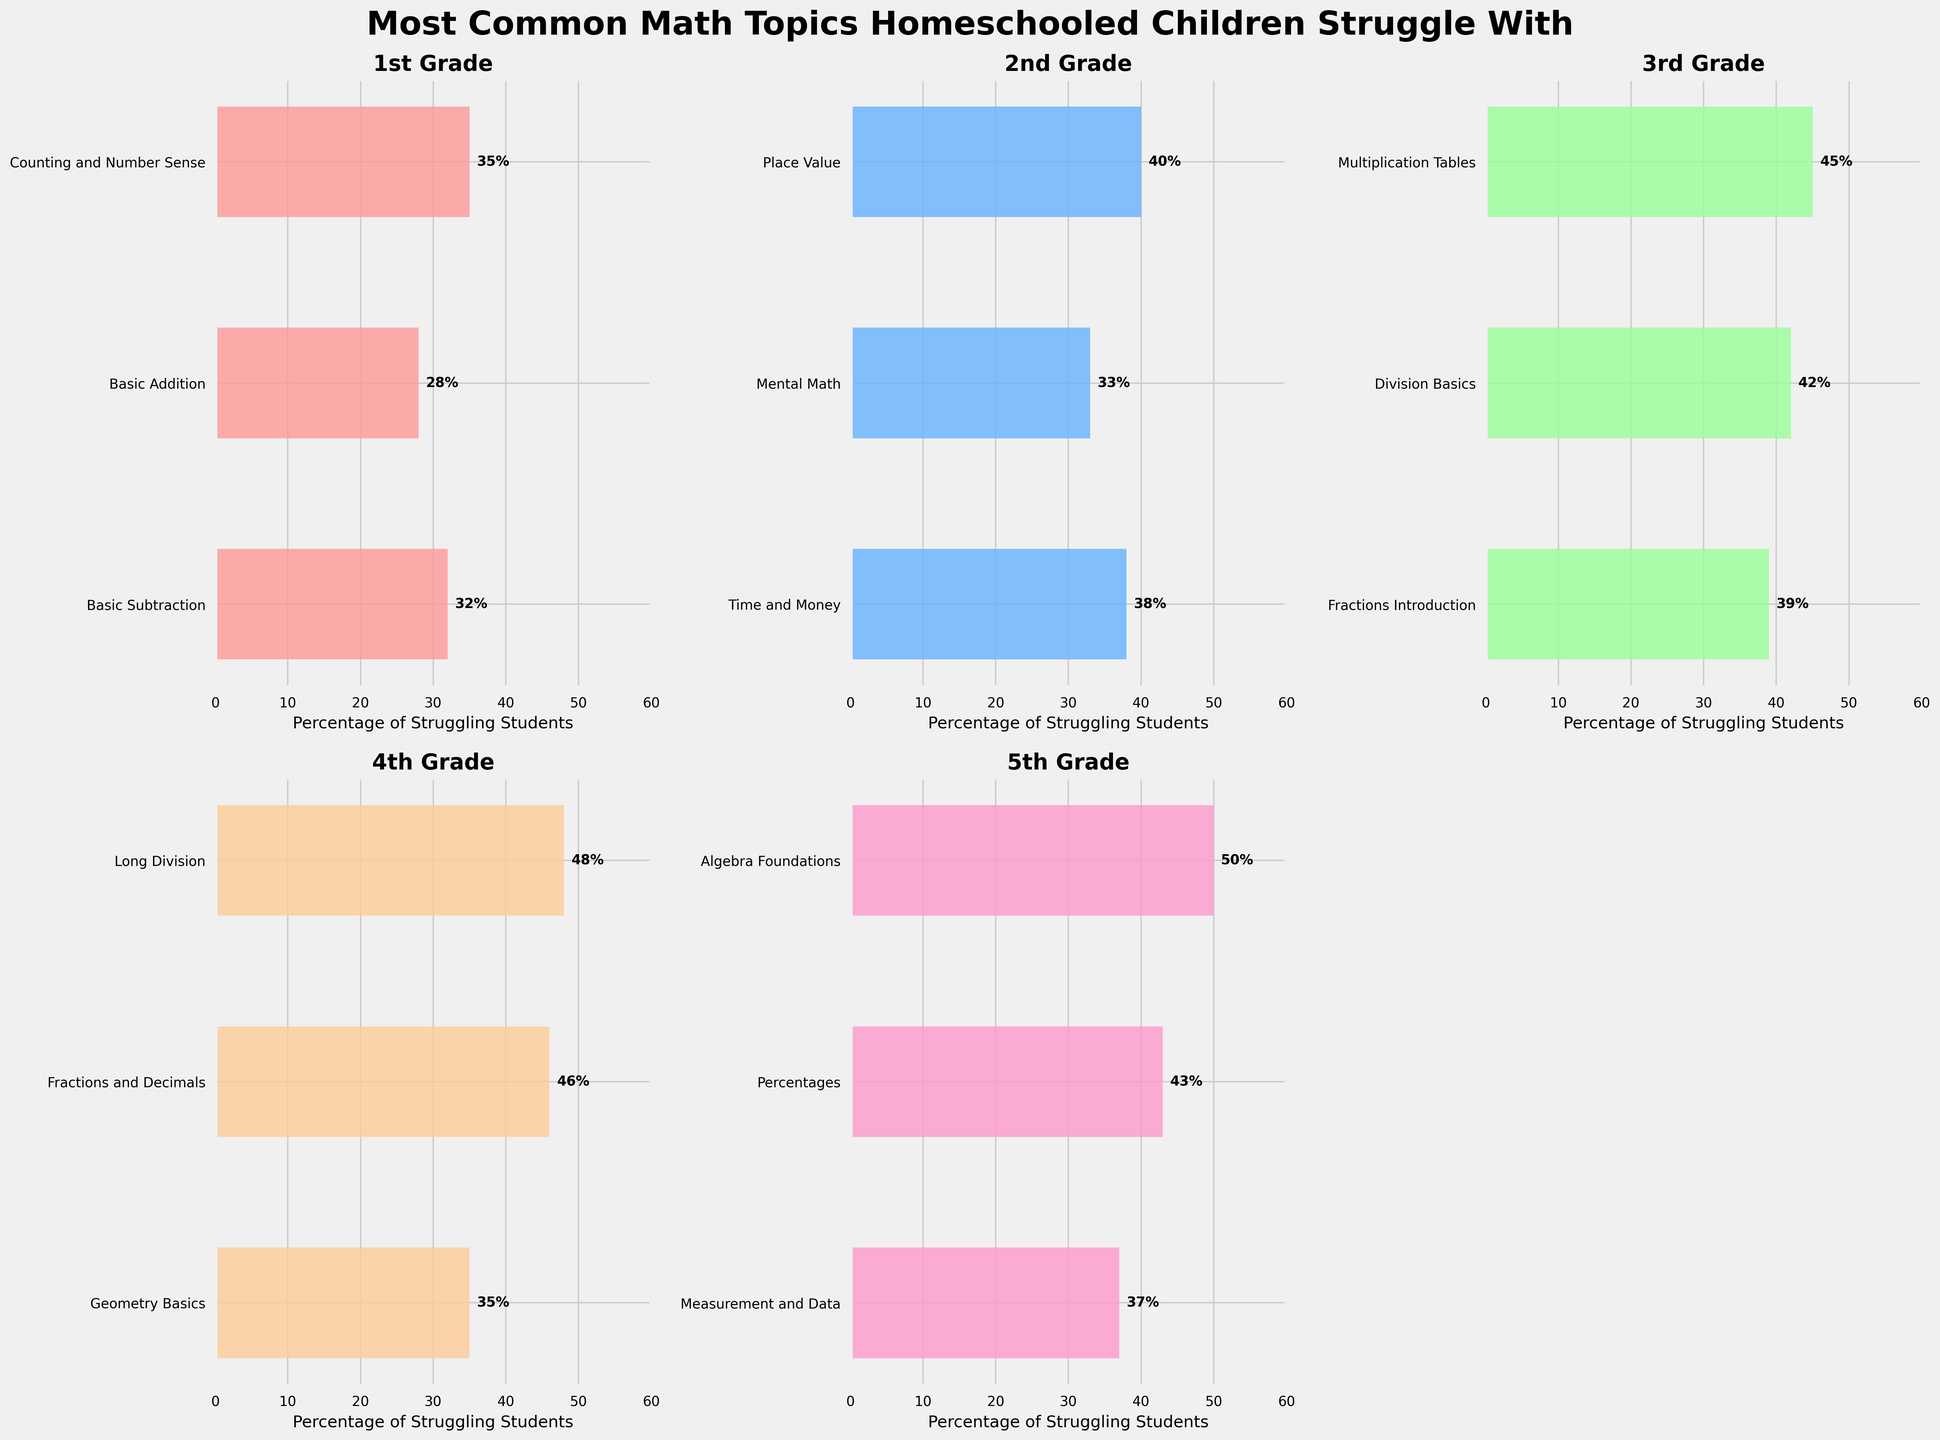What's the most common math topic that 3rd graders struggle with? The topic with the highest percentage of struggling students for 3rd grade is identified by looking at the longest bar in the 3rd-grade plot, which is 'Multiplication Tables' at 45%.
Answer: Multiplication Tables Which grade has the highest percentage of students struggling with a specific topic? We need to identify the grade with the maximum percentage from all the bars in all subplots. The highest is 'Ratios and Proportions' in 6th grade at 52%.
Answer: 6th grade Among 4th-grade topics, which has the lowest percentage of students struggling? In the 4th-grade subplot, the shortest bar represents 'Geometry Basics' with a percentage of 35%.
Answer: Geometry Basics Compare the percentages of students struggling with 'Fractions Introduction' in 3rd grade to 'Fractions and Decimals' in 4th grade. Which is higher? 'Fractions Introduction' in 3rd grade is at 39%, while 'Fractions and Decimals' in 4th grade is at 46%. Comparatively, 46% is higher than 39%.
Answer: Fractions and Decimals What is the total percentage of students struggling with 'Basic Addition' and 'Basic Subtraction' in 1st grade? Sum the percentages for 'Basic Addition' (28%) and 'Basic Subtraction' (32%) in 1st grade, which results in 28% + 32% = 60%.
Answer: 60% How does the percentage of students struggling with 'Algebra Foundations' in 5th grade compare with 'Pre-Algebra Concepts' in 6th grade? 'Algebra Foundations' has 50% in 5th grade, and 'Pre-Algebra Concepts' has 49% in 6th grade. 50% is slightly higher than 49%.
Answer: Algebra Foundations What is the average percentage of struggling students for the topics in 2nd grade? Calculate the average of the percentages for 2nd grade: (40% + 33% + 38%) / 3 = 111% / 3 = 37%.
Answer: 37% Which grade shows the most diverse percentage range between the highest and lowest topics? Calculate the range for each grade by subtracting the lowest percentage from the highest. The largest range is in 6th grade with 52% - 47% = 5%, which is the greatest among all grades.
Answer: 6th grade What is the visual color representing the 1st-grade topics? Identify the color used for the bars in the 1st-grade subplot. The bars are shown in a red shade.
Answer: Red What’s the median percentage for struggling students among the topics in 5th grade? Arrange the percentages for 5th grade (50%, 43%, and 37%) in order: 37%, 43%, 50%. The middle value is the median, which is 43%.
Answer: 43% 